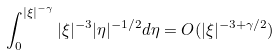<formula> <loc_0><loc_0><loc_500><loc_500>\int _ { 0 } ^ { | \xi | ^ { - \gamma } } | \xi | ^ { - 3 } | \eta | ^ { - 1 / 2 } d \eta = O ( | \xi | ^ { - 3 + \gamma / 2 } )</formula> 